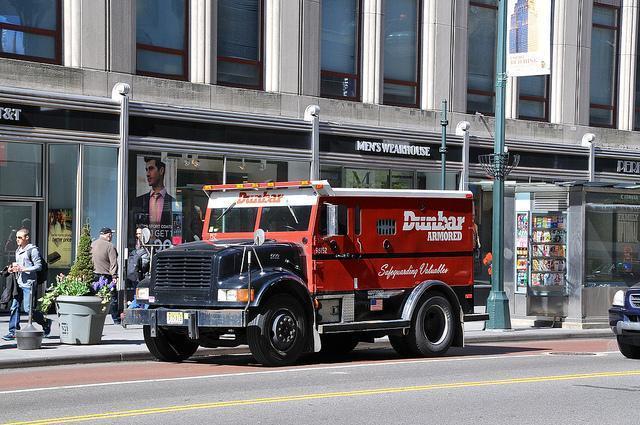How many people are visible?
Give a very brief answer. 2. How many orange lights can you see on the motorcycle?
Give a very brief answer. 0. 